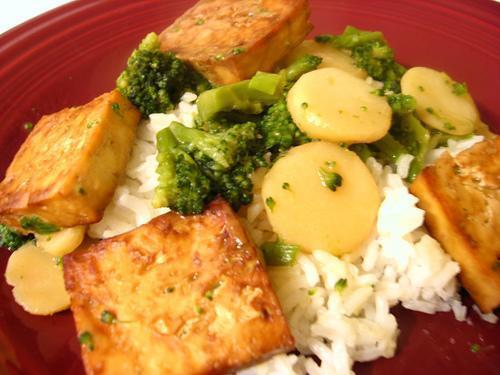How many biscuits are pictured?
Give a very brief answer. 4. 